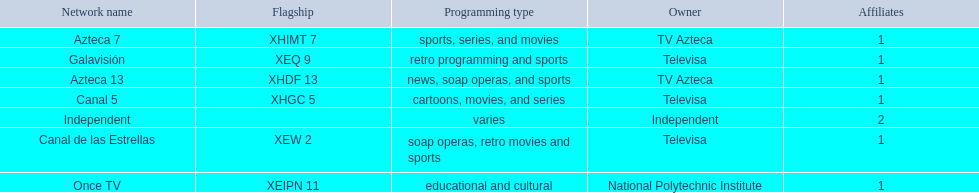Which owner only owns one network? National Polytechnic Institute, Independent. Of those, what is the network name? Once TV, Independent. Of those, which programming type is educational and cultural? Once TV. 